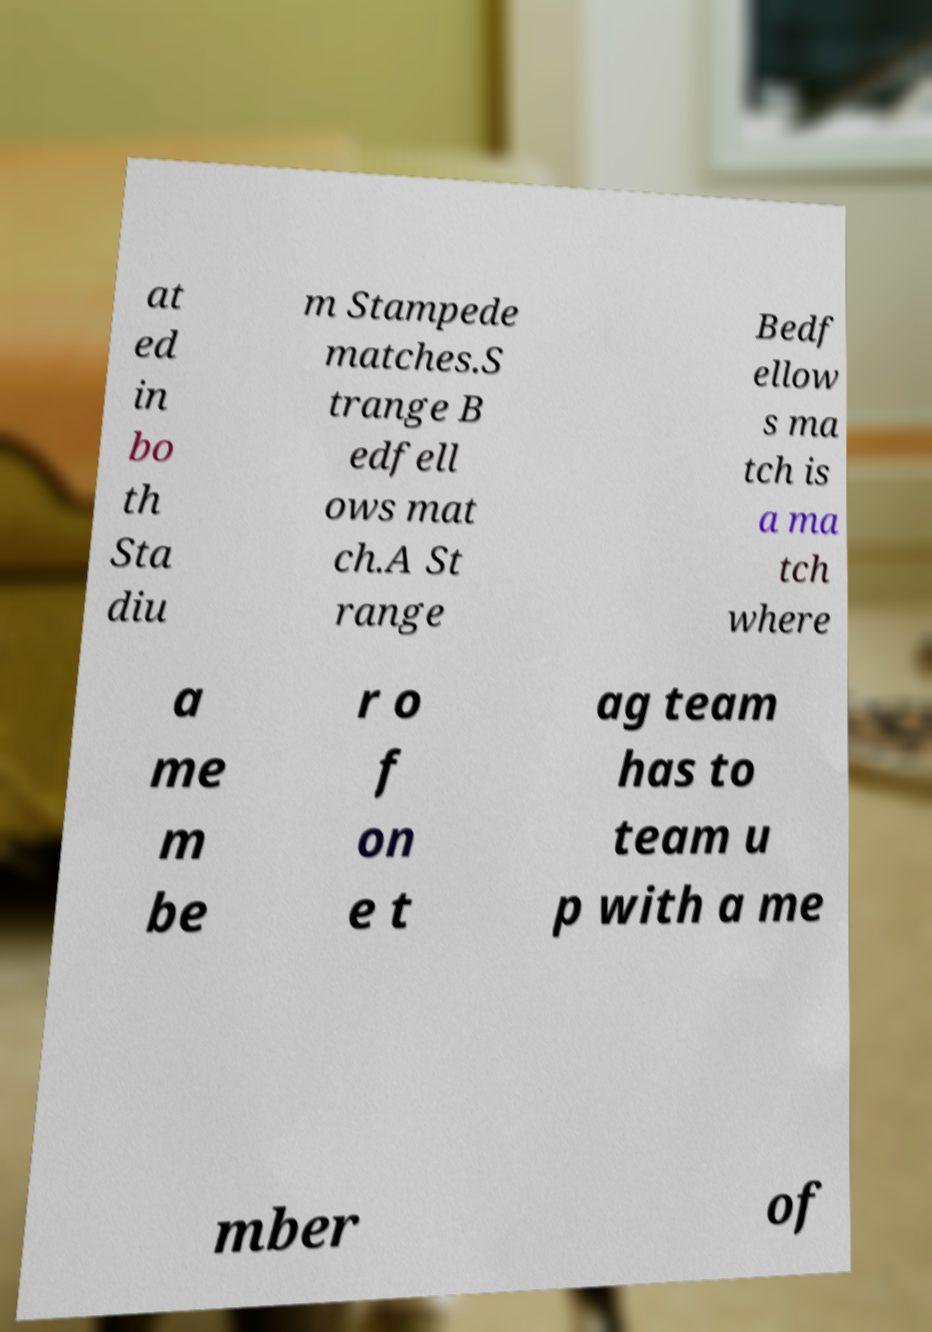Please identify and transcribe the text found in this image. at ed in bo th Sta diu m Stampede matches.S trange B edfell ows mat ch.A St range Bedf ellow s ma tch is a ma tch where a me m be r o f on e t ag team has to team u p with a me mber of 